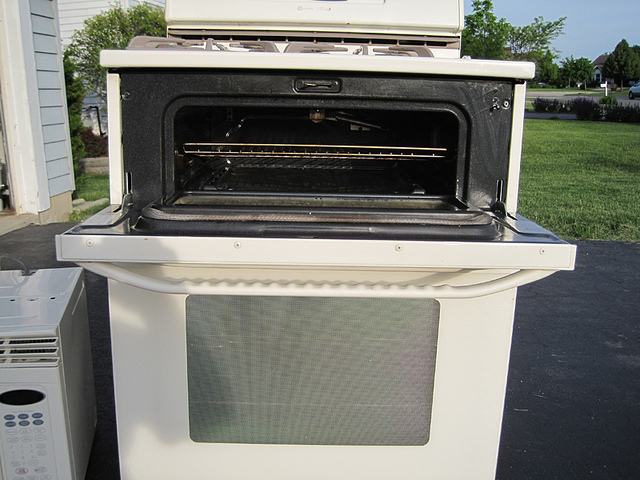<image>What kind of food can you cook in that toaster oven? It is ambiguous what kind of food can be cooked in the toaster oven. However, commonly it can be used for toasts, bagels or pizza. What kind of food can you cook in that toaster oven? It is unanswerable what kind of food can be cooked in that toaster oven. 